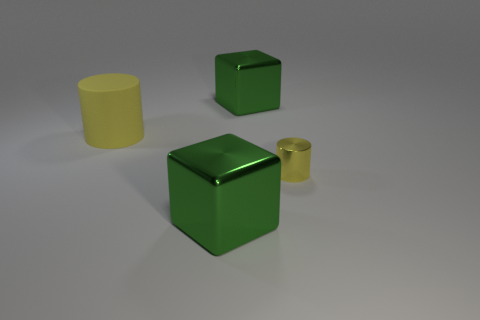Add 4 tiny red metallic things. How many objects exist? 8 Subtract all large purple rubber blocks. Subtract all yellow objects. How many objects are left? 2 Add 1 big green cubes. How many big green cubes are left? 3 Add 3 small matte cylinders. How many small matte cylinders exist? 3 Subtract 2 yellow cylinders. How many objects are left? 2 